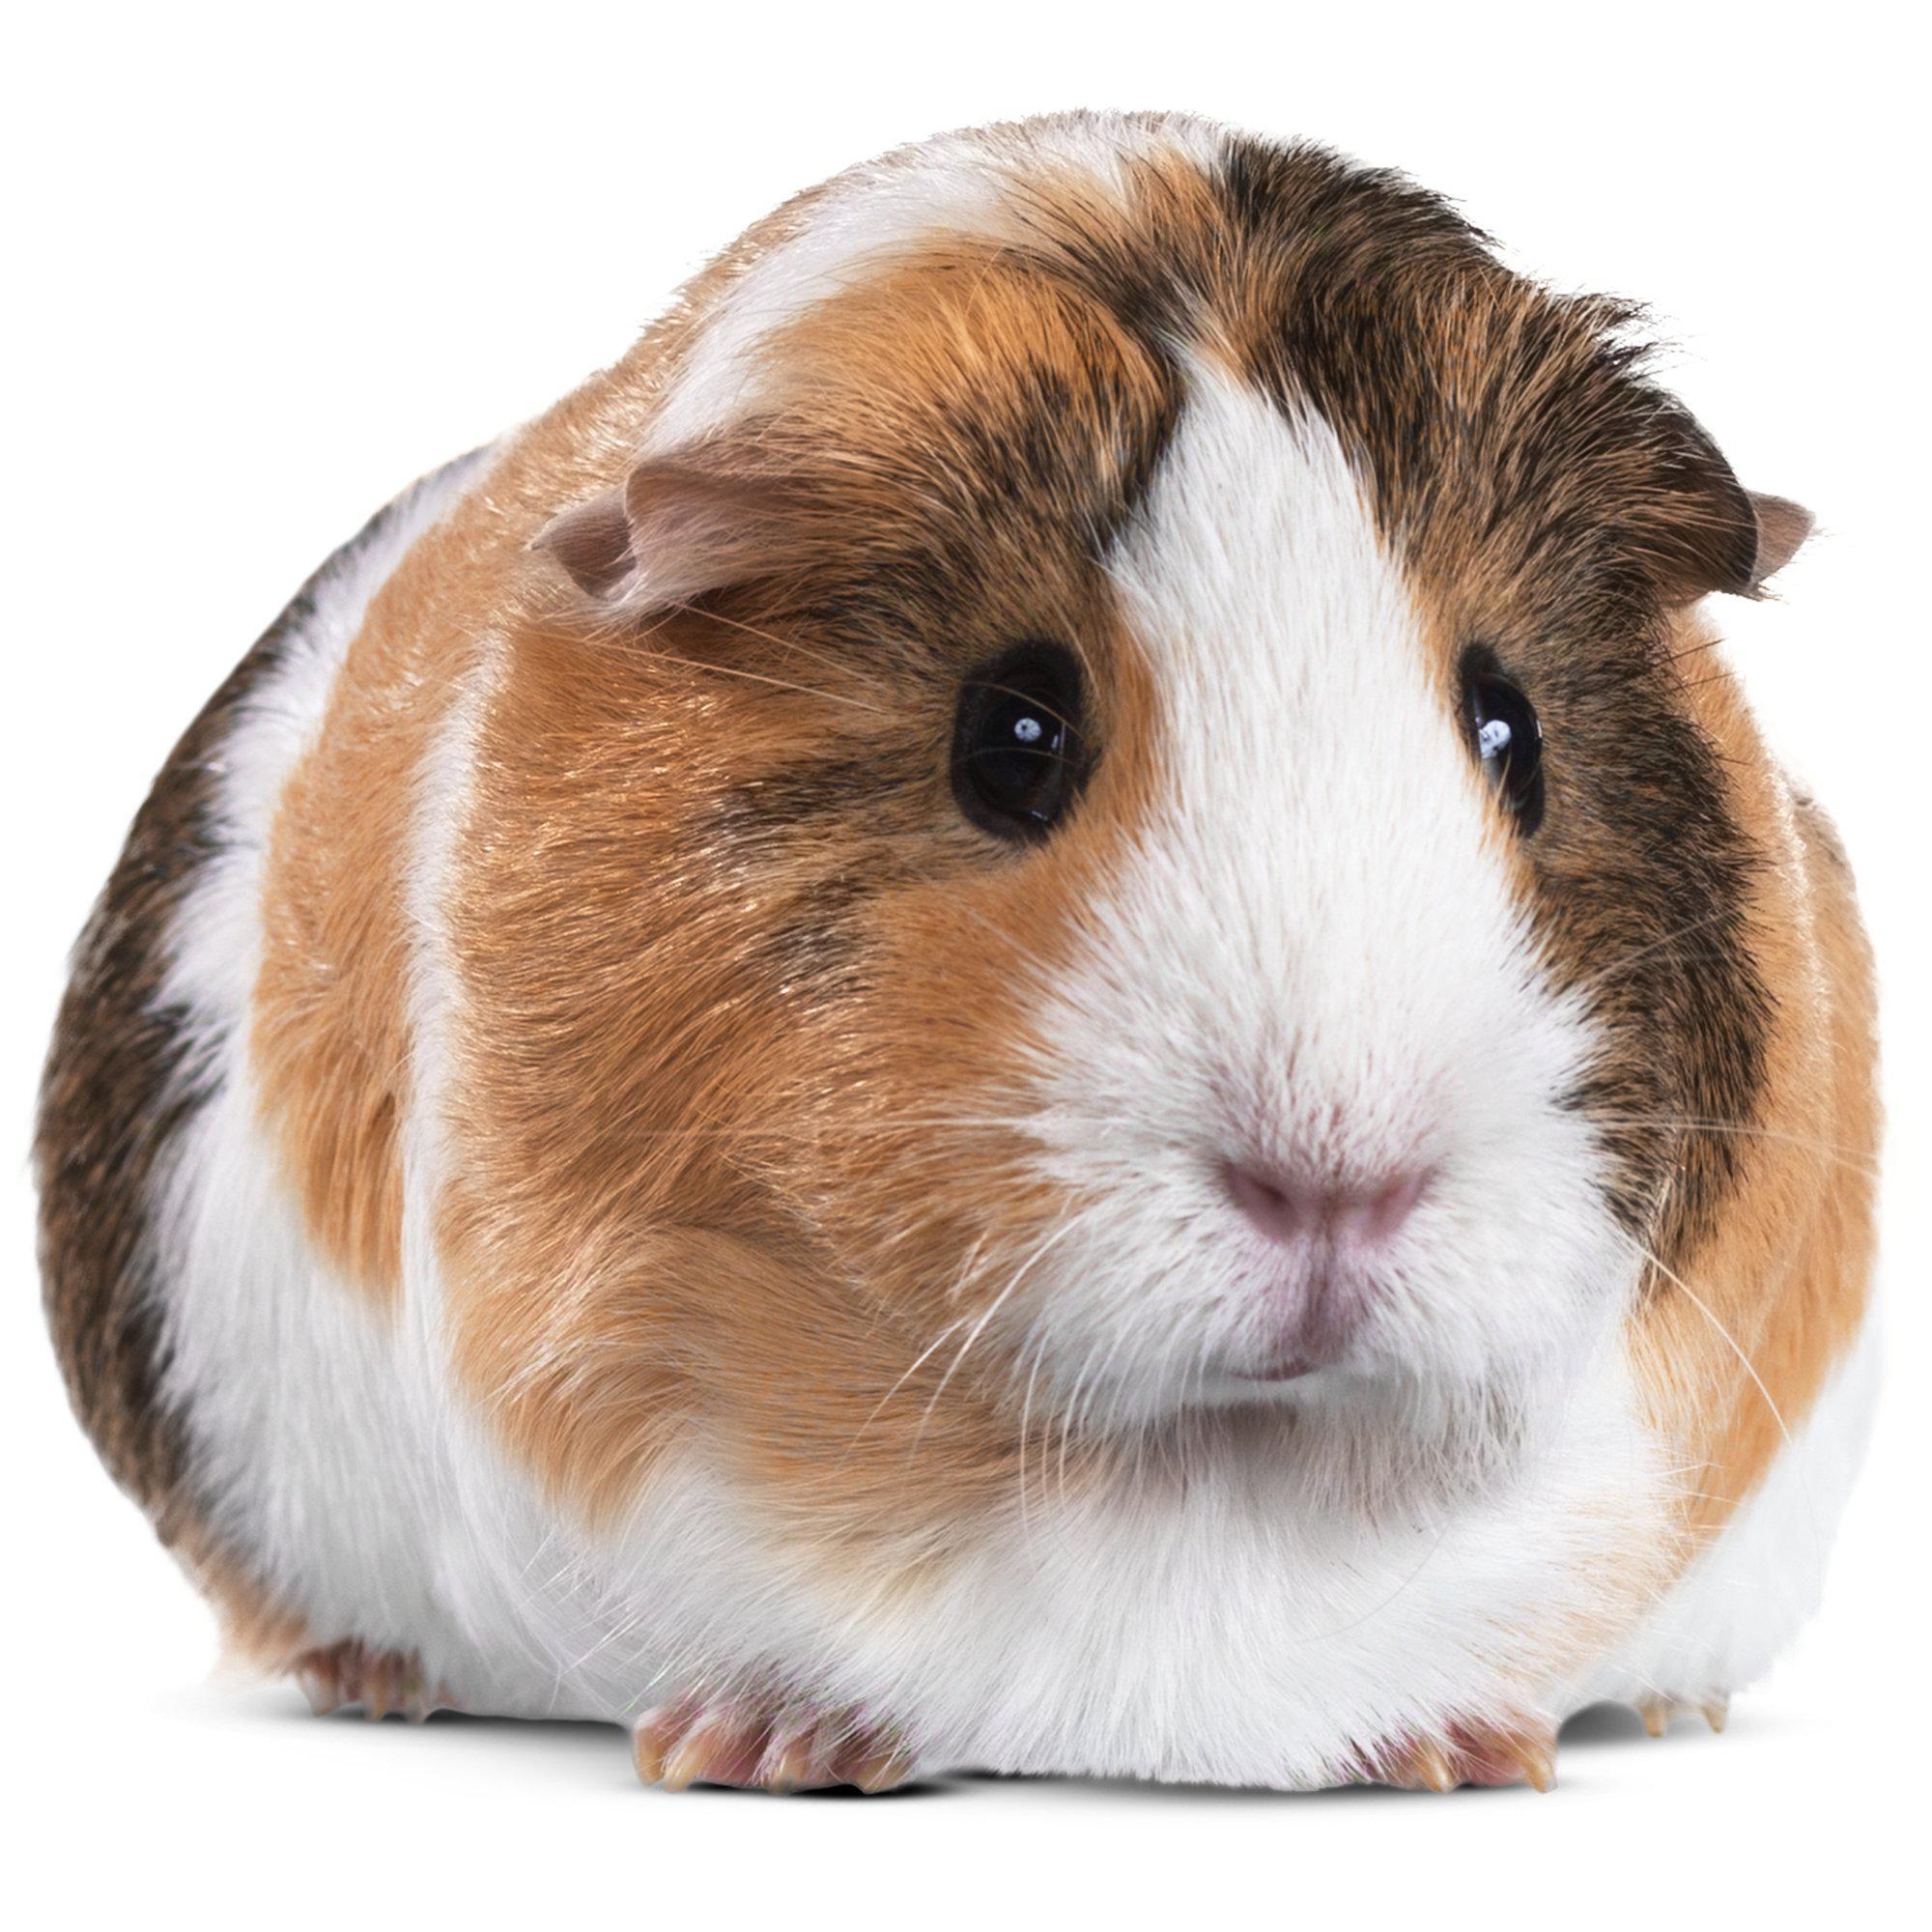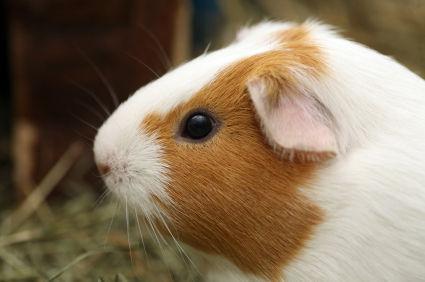The first image is the image on the left, the second image is the image on the right. Given the left and right images, does the statement "The hamster on the right is depicted with produce-type food." hold true? Answer yes or no. No. 